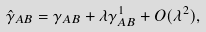Convert formula to latex. <formula><loc_0><loc_0><loc_500><loc_500>\hat { \gamma } _ { A B } = \gamma _ { A B } + \lambda \gamma ^ { 1 } _ { A B } + O ( \lambda ^ { 2 } ) ,</formula> 